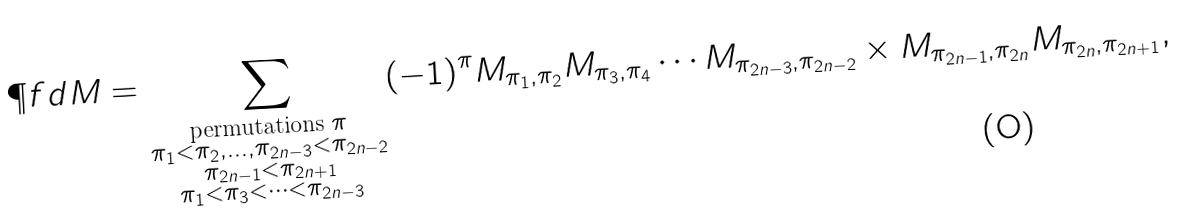<formula> <loc_0><loc_0><loc_500><loc_500>\P f d M = \sum _ { \substack { \text {permutations $\pi$} \\ \pi _ { 1 } < \pi _ { 2 } , \dots , \pi _ { 2 n - 3 } < \pi _ { 2 n - 2 } \\ \pi _ { 2 n - 1 } < \pi _ { 2 n + 1 } \\ \pi _ { 1 } < \pi _ { 3 } < \cdots < \pi _ { 2 n - 3 } } } ( - 1 ) ^ { \pi } M _ { \pi _ { 1 } , \pi _ { 2 } } M _ { \pi _ { 3 } , \pi _ { 4 } } \cdots M _ { \pi _ { 2 n - 3 } , \pi _ { 2 n - 2 } } \times M _ { \pi _ { 2 n - 1 } , \pi _ { 2 n } } M _ { \pi _ { 2 n } , \pi _ { 2 n + 1 } } ,</formula> 